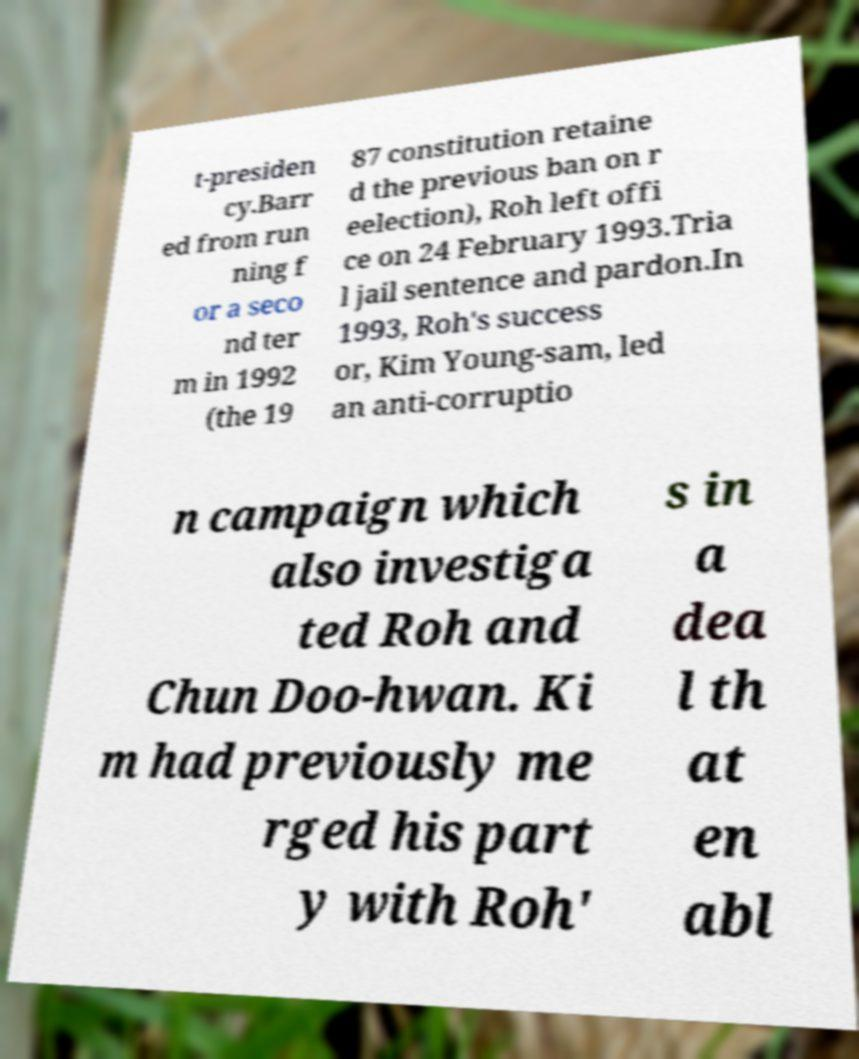Can you accurately transcribe the text from the provided image for me? t-presiden cy.Barr ed from run ning f or a seco nd ter m in 1992 (the 19 87 constitution retaine d the previous ban on r eelection), Roh left offi ce on 24 February 1993.Tria l jail sentence and pardon.In 1993, Roh's success or, Kim Young-sam, led an anti-corruptio n campaign which also investiga ted Roh and Chun Doo-hwan. Ki m had previously me rged his part y with Roh' s in a dea l th at en abl 